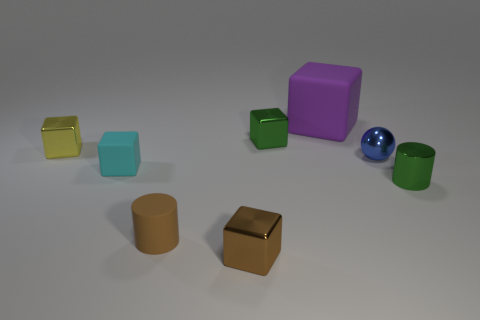What is the material of the small thing that is the same color as the metal cylinder?
Ensure brevity in your answer.  Metal. How many other things are there of the same shape as the purple matte object?
Make the answer very short. 4. Is the yellow object the same shape as the blue object?
Keep it short and to the point. No. The tiny thing that is in front of the shiny cylinder and behind the brown metal thing is what color?
Keep it short and to the point. Brown. What is the size of the metal cube that is the same color as the tiny rubber cylinder?
Offer a very short reply. Small. What number of small objects are either blue things or red objects?
Your answer should be very brief. 1. Is there any other thing that is the same color as the rubber cylinder?
Offer a very short reply. Yes. There is a cylinder to the right of the green object that is left of the blue object to the right of the big purple block; what is its material?
Your answer should be compact. Metal. What number of rubber things are either large blue cubes or blue things?
Provide a succinct answer. 0. What number of red things are either rubber things or small matte things?
Offer a very short reply. 0. 